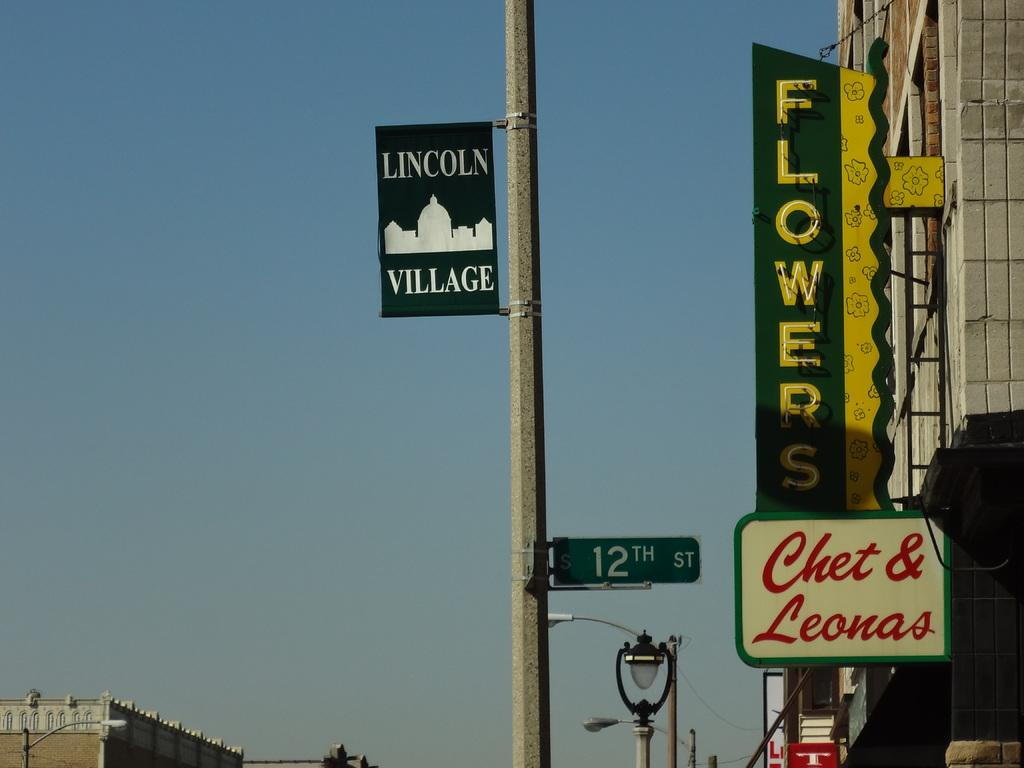<image>
Write a terse but informative summary of the picture. Sign outside of a building which says "Flowers" on it. 